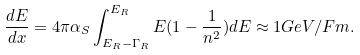Convert formula to latex. <formula><loc_0><loc_0><loc_500><loc_500>\frac { d E } { d x } = 4 \pi \alpha _ { S } \int _ { E _ { R } - \Gamma _ { R } } ^ { E _ { R } } E ( 1 - \frac { 1 } { n ^ { 2 } } ) d E \approx 1 G e V / F m .</formula> 